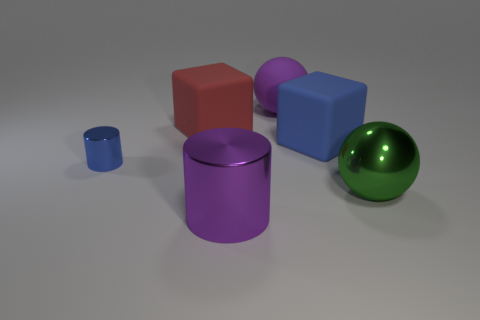Is there any other thing that has the same color as the tiny object?
Keep it short and to the point. Yes. What size is the sphere that is on the left side of the big green ball?
Your response must be concise. Large. There is a big metallic sphere; is it the same color as the metallic cylinder right of the small blue thing?
Make the answer very short. No. How many other things are there of the same material as the big blue cube?
Your answer should be compact. 2. Are there more green metallic objects than big purple cubes?
Provide a short and direct response. Yes. There is a big metal thing that is to the left of the big green shiny sphere; is its color the same as the big matte sphere?
Offer a terse response. Yes. The big matte ball is what color?
Keep it short and to the point. Purple. There is a large matte cube that is left of the purple metal thing; are there any purple things that are in front of it?
Offer a very short reply. Yes. The blue thing on the left side of the large purple object that is in front of the purple rubber sphere is what shape?
Provide a short and direct response. Cylinder. Is the number of blue metal things less than the number of cyan metal cubes?
Your response must be concise. No. 